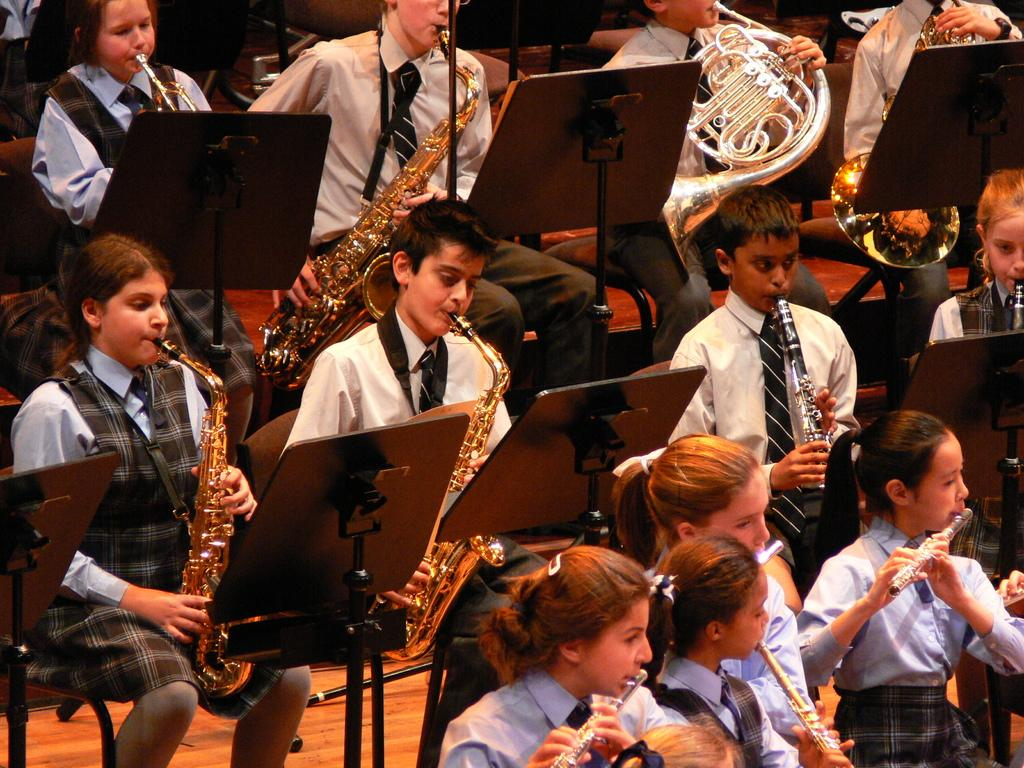What are the people in the image doing? The people in the image are students. What activity are the students engaged in? The students are playing musical instruments. What tool are the students using to assist with their music? The students are using a musical notepad. What type of bean is being discussed by the students in the image? There is no bean or discussion about a bean present in the image. 